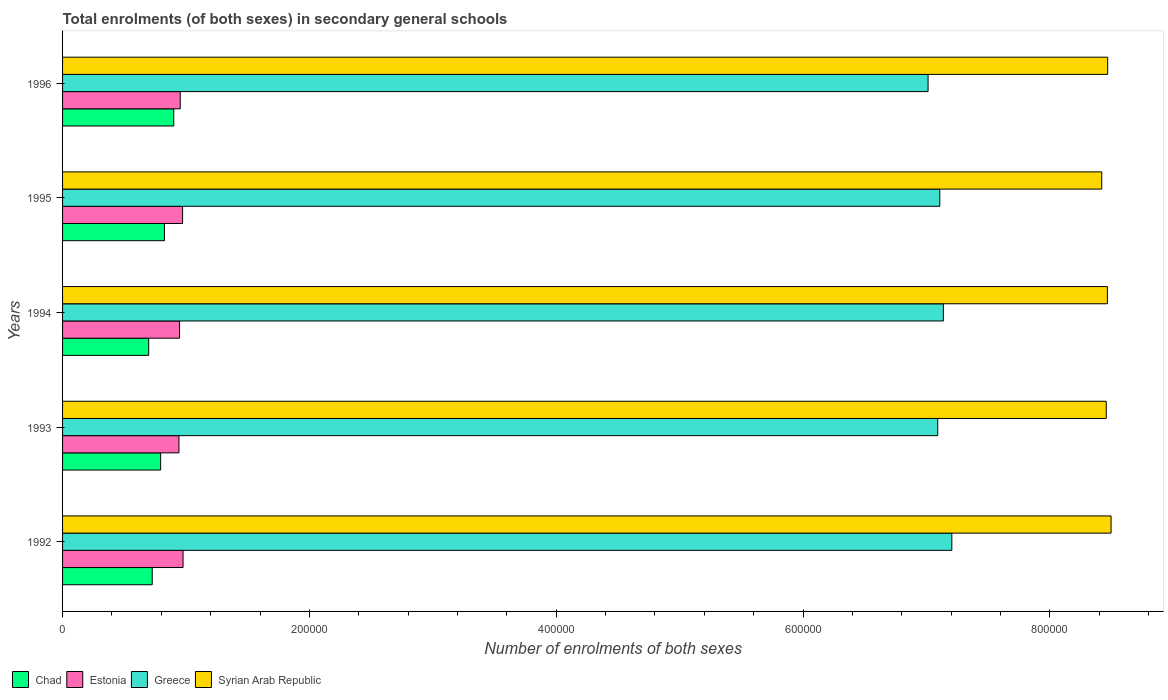How many groups of bars are there?
Keep it short and to the point. 5. How many bars are there on the 2nd tick from the top?
Make the answer very short. 4. How many bars are there on the 3rd tick from the bottom?
Your answer should be very brief. 4. What is the number of enrolments in secondary schools in Chad in 1992?
Your answer should be compact. 7.26e+04. Across all years, what is the maximum number of enrolments in secondary schools in Chad?
Make the answer very short. 9.01e+04. Across all years, what is the minimum number of enrolments in secondary schools in Syrian Arab Republic?
Give a very brief answer. 8.42e+05. In which year was the number of enrolments in secondary schools in Chad maximum?
Provide a succinct answer. 1996. In which year was the number of enrolments in secondary schools in Greece minimum?
Make the answer very short. 1996. What is the total number of enrolments in secondary schools in Chad in the graph?
Keep it short and to the point. 3.95e+05. What is the difference between the number of enrolments in secondary schools in Estonia in 1992 and that in 1993?
Give a very brief answer. 3318. What is the difference between the number of enrolments in secondary schools in Syrian Arab Republic in 1992 and the number of enrolments in secondary schools in Chad in 1996?
Your answer should be very brief. 7.59e+05. What is the average number of enrolments in secondary schools in Syrian Arab Republic per year?
Keep it short and to the point. 8.46e+05. In the year 1994, what is the difference between the number of enrolments in secondary schools in Syrian Arab Republic and number of enrolments in secondary schools in Estonia?
Make the answer very short. 7.52e+05. In how many years, is the number of enrolments in secondary schools in Estonia greater than 760000 ?
Provide a short and direct response. 0. What is the ratio of the number of enrolments in secondary schools in Greece in 1994 to that in 1995?
Your answer should be compact. 1. What is the difference between the highest and the second highest number of enrolments in secondary schools in Chad?
Offer a terse response. 7541. What is the difference between the highest and the lowest number of enrolments in secondary schools in Greece?
Offer a terse response. 1.92e+04. In how many years, is the number of enrolments in secondary schools in Syrian Arab Republic greater than the average number of enrolments in secondary schools in Syrian Arab Republic taken over all years?
Give a very brief answer. 3. Is the sum of the number of enrolments in secondary schools in Greece in 1992 and 1994 greater than the maximum number of enrolments in secondary schools in Estonia across all years?
Your response must be concise. Yes. Is it the case that in every year, the sum of the number of enrolments in secondary schools in Syrian Arab Republic and number of enrolments in secondary schools in Greece is greater than the sum of number of enrolments in secondary schools in Estonia and number of enrolments in secondary schools in Chad?
Your answer should be very brief. Yes. What does the 3rd bar from the top in 1993 represents?
Give a very brief answer. Estonia. What does the 1st bar from the bottom in 1995 represents?
Offer a very short reply. Chad. Is it the case that in every year, the sum of the number of enrolments in secondary schools in Chad and number of enrolments in secondary schools in Greece is greater than the number of enrolments in secondary schools in Syrian Arab Republic?
Make the answer very short. No. Are all the bars in the graph horizontal?
Give a very brief answer. Yes. Does the graph contain any zero values?
Ensure brevity in your answer.  No. Does the graph contain grids?
Your answer should be compact. No. Where does the legend appear in the graph?
Your answer should be very brief. Bottom left. How are the legend labels stacked?
Give a very brief answer. Horizontal. What is the title of the graph?
Your answer should be compact. Total enrolments (of both sexes) in secondary general schools. What is the label or title of the X-axis?
Keep it short and to the point. Number of enrolments of both sexes. What is the Number of enrolments of both sexes in Chad in 1992?
Your answer should be very brief. 7.26e+04. What is the Number of enrolments of both sexes in Estonia in 1992?
Your answer should be compact. 9.76e+04. What is the Number of enrolments of both sexes in Greece in 1992?
Offer a terse response. 7.21e+05. What is the Number of enrolments of both sexes in Syrian Arab Republic in 1992?
Provide a short and direct response. 8.50e+05. What is the Number of enrolments of both sexes of Chad in 1993?
Provide a succinct answer. 7.95e+04. What is the Number of enrolments of both sexes of Estonia in 1993?
Keep it short and to the point. 9.43e+04. What is the Number of enrolments of both sexes of Greece in 1993?
Your answer should be compact. 7.09e+05. What is the Number of enrolments of both sexes in Syrian Arab Republic in 1993?
Offer a very short reply. 8.46e+05. What is the Number of enrolments of both sexes in Chad in 1994?
Make the answer very short. 6.98e+04. What is the Number of enrolments of both sexes in Estonia in 1994?
Provide a short and direct response. 9.48e+04. What is the Number of enrolments of both sexes in Greece in 1994?
Your answer should be very brief. 7.14e+05. What is the Number of enrolments of both sexes in Syrian Arab Republic in 1994?
Ensure brevity in your answer.  8.47e+05. What is the Number of enrolments of both sexes in Chad in 1995?
Make the answer very short. 8.26e+04. What is the Number of enrolments of both sexes of Estonia in 1995?
Provide a succinct answer. 9.72e+04. What is the Number of enrolments of both sexes of Greece in 1995?
Give a very brief answer. 7.11e+05. What is the Number of enrolments of both sexes in Syrian Arab Republic in 1995?
Offer a very short reply. 8.42e+05. What is the Number of enrolments of both sexes of Chad in 1996?
Give a very brief answer. 9.01e+04. What is the Number of enrolments of both sexes in Estonia in 1996?
Make the answer very short. 9.53e+04. What is the Number of enrolments of both sexes in Greece in 1996?
Provide a short and direct response. 7.01e+05. What is the Number of enrolments of both sexes of Syrian Arab Republic in 1996?
Your answer should be compact. 8.47e+05. Across all years, what is the maximum Number of enrolments of both sexes in Chad?
Make the answer very short. 9.01e+04. Across all years, what is the maximum Number of enrolments of both sexes in Estonia?
Provide a short and direct response. 9.76e+04. Across all years, what is the maximum Number of enrolments of both sexes in Greece?
Your answer should be very brief. 7.21e+05. Across all years, what is the maximum Number of enrolments of both sexes in Syrian Arab Republic?
Keep it short and to the point. 8.50e+05. Across all years, what is the minimum Number of enrolments of both sexes in Chad?
Ensure brevity in your answer.  6.98e+04. Across all years, what is the minimum Number of enrolments of both sexes of Estonia?
Your answer should be compact. 9.43e+04. Across all years, what is the minimum Number of enrolments of both sexes of Greece?
Provide a succinct answer. 7.01e+05. Across all years, what is the minimum Number of enrolments of both sexes of Syrian Arab Republic?
Your answer should be very brief. 8.42e+05. What is the total Number of enrolments of both sexes in Chad in the graph?
Make the answer very short. 3.95e+05. What is the total Number of enrolments of both sexes in Estonia in the graph?
Your response must be concise. 4.79e+05. What is the total Number of enrolments of both sexes of Greece in the graph?
Provide a short and direct response. 3.56e+06. What is the total Number of enrolments of both sexes of Syrian Arab Republic in the graph?
Provide a short and direct response. 4.23e+06. What is the difference between the Number of enrolments of both sexes of Chad in 1992 and that in 1993?
Offer a very short reply. -6817. What is the difference between the Number of enrolments of both sexes in Estonia in 1992 and that in 1993?
Ensure brevity in your answer.  3318. What is the difference between the Number of enrolments of both sexes in Greece in 1992 and that in 1993?
Offer a terse response. 1.14e+04. What is the difference between the Number of enrolments of both sexes in Syrian Arab Republic in 1992 and that in 1993?
Make the answer very short. 3899. What is the difference between the Number of enrolments of both sexes of Chad in 1992 and that in 1994?
Provide a succinct answer. 2857. What is the difference between the Number of enrolments of both sexes of Estonia in 1992 and that in 1994?
Give a very brief answer. 2845. What is the difference between the Number of enrolments of both sexes in Greece in 1992 and that in 1994?
Provide a succinct answer. 6852. What is the difference between the Number of enrolments of both sexes in Syrian Arab Republic in 1992 and that in 1994?
Offer a terse response. 2980. What is the difference between the Number of enrolments of both sexes in Chad in 1992 and that in 1995?
Your answer should be very brief. -9918. What is the difference between the Number of enrolments of both sexes of Estonia in 1992 and that in 1995?
Offer a terse response. 379. What is the difference between the Number of enrolments of both sexes in Greece in 1992 and that in 1995?
Keep it short and to the point. 9752. What is the difference between the Number of enrolments of both sexes in Syrian Arab Republic in 1992 and that in 1995?
Keep it short and to the point. 7566. What is the difference between the Number of enrolments of both sexes of Chad in 1992 and that in 1996?
Keep it short and to the point. -1.75e+04. What is the difference between the Number of enrolments of both sexes in Estonia in 1992 and that in 1996?
Give a very brief answer. 2283. What is the difference between the Number of enrolments of both sexes in Greece in 1992 and that in 1996?
Provide a short and direct response. 1.92e+04. What is the difference between the Number of enrolments of both sexes in Syrian Arab Republic in 1992 and that in 1996?
Offer a very short reply. 2752. What is the difference between the Number of enrolments of both sexes of Chad in 1993 and that in 1994?
Your response must be concise. 9674. What is the difference between the Number of enrolments of both sexes in Estonia in 1993 and that in 1994?
Provide a short and direct response. -473. What is the difference between the Number of enrolments of both sexes in Greece in 1993 and that in 1994?
Offer a very short reply. -4578. What is the difference between the Number of enrolments of both sexes in Syrian Arab Republic in 1993 and that in 1994?
Offer a terse response. -919. What is the difference between the Number of enrolments of both sexes of Chad in 1993 and that in 1995?
Keep it short and to the point. -3101. What is the difference between the Number of enrolments of both sexes in Estonia in 1993 and that in 1995?
Ensure brevity in your answer.  -2939. What is the difference between the Number of enrolments of both sexes of Greece in 1993 and that in 1995?
Provide a succinct answer. -1678. What is the difference between the Number of enrolments of both sexes of Syrian Arab Republic in 1993 and that in 1995?
Make the answer very short. 3667. What is the difference between the Number of enrolments of both sexes in Chad in 1993 and that in 1996?
Make the answer very short. -1.06e+04. What is the difference between the Number of enrolments of both sexes in Estonia in 1993 and that in 1996?
Offer a very short reply. -1035. What is the difference between the Number of enrolments of both sexes in Greece in 1993 and that in 1996?
Provide a short and direct response. 7818. What is the difference between the Number of enrolments of both sexes in Syrian Arab Republic in 1993 and that in 1996?
Your answer should be compact. -1147. What is the difference between the Number of enrolments of both sexes in Chad in 1994 and that in 1995?
Ensure brevity in your answer.  -1.28e+04. What is the difference between the Number of enrolments of both sexes in Estonia in 1994 and that in 1995?
Provide a succinct answer. -2466. What is the difference between the Number of enrolments of both sexes of Greece in 1994 and that in 1995?
Provide a succinct answer. 2900. What is the difference between the Number of enrolments of both sexes in Syrian Arab Republic in 1994 and that in 1995?
Offer a very short reply. 4586. What is the difference between the Number of enrolments of both sexes in Chad in 1994 and that in 1996?
Give a very brief answer. -2.03e+04. What is the difference between the Number of enrolments of both sexes of Estonia in 1994 and that in 1996?
Give a very brief answer. -562. What is the difference between the Number of enrolments of both sexes of Greece in 1994 and that in 1996?
Make the answer very short. 1.24e+04. What is the difference between the Number of enrolments of both sexes in Syrian Arab Republic in 1994 and that in 1996?
Make the answer very short. -228. What is the difference between the Number of enrolments of both sexes of Chad in 1995 and that in 1996?
Make the answer very short. -7541. What is the difference between the Number of enrolments of both sexes of Estonia in 1995 and that in 1996?
Provide a short and direct response. 1904. What is the difference between the Number of enrolments of both sexes of Greece in 1995 and that in 1996?
Your answer should be very brief. 9496. What is the difference between the Number of enrolments of both sexes in Syrian Arab Republic in 1995 and that in 1996?
Your response must be concise. -4814. What is the difference between the Number of enrolments of both sexes of Chad in 1992 and the Number of enrolments of both sexes of Estonia in 1993?
Provide a short and direct response. -2.17e+04. What is the difference between the Number of enrolments of both sexes in Chad in 1992 and the Number of enrolments of both sexes in Greece in 1993?
Provide a short and direct response. -6.36e+05. What is the difference between the Number of enrolments of both sexes in Chad in 1992 and the Number of enrolments of both sexes in Syrian Arab Republic in 1993?
Your response must be concise. -7.73e+05. What is the difference between the Number of enrolments of both sexes of Estonia in 1992 and the Number of enrolments of both sexes of Greece in 1993?
Offer a very short reply. -6.11e+05. What is the difference between the Number of enrolments of both sexes in Estonia in 1992 and the Number of enrolments of both sexes in Syrian Arab Republic in 1993?
Give a very brief answer. -7.48e+05. What is the difference between the Number of enrolments of both sexes in Greece in 1992 and the Number of enrolments of both sexes in Syrian Arab Republic in 1993?
Make the answer very short. -1.25e+05. What is the difference between the Number of enrolments of both sexes in Chad in 1992 and the Number of enrolments of both sexes in Estonia in 1994?
Ensure brevity in your answer.  -2.21e+04. What is the difference between the Number of enrolments of both sexes of Chad in 1992 and the Number of enrolments of both sexes of Greece in 1994?
Your answer should be compact. -6.41e+05. What is the difference between the Number of enrolments of both sexes of Chad in 1992 and the Number of enrolments of both sexes of Syrian Arab Republic in 1994?
Keep it short and to the point. -7.74e+05. What is the difference between the Number of enrolments of both sexes in Estonia in 1992 and the Number of enrolments of both sexes in Greece in 1994?
Provide a succinct answer. -6.16e+05. What is the difference between the Number of enrolments of both sexes of Estonia in 1992 and the Number of enrolments of both sexes of Syrian Arab Republic in 1994?
Make the answer very short. -7.49e+05. What is the difference between the Number of enrolments of both sexes in Greece in 1992 and the Number of enrolments of both sexes in Syrian Arab Republic in 1994?
Keep it short and to the point. -1.26e+05. What is the difference between the Number of enrolments of both sexes in Chad in 1992 and the Number of enrolments of both sexes in Estonia in 1995?
Give a very brief answer. -2.46e+04. What is the difference between the Number of enrolments of both sexes in Chad in 1992 and the Number of enrolments of both sexes in Greece in 1995?
Provide a short and direct response. -6.38e+05. What is the difference between the Number of enrolments of both sexes in Chad in 1992 and the Number of enrolments of both sexes in Syrian Arab Republic in 1995?
Keep it short and to the point. -7.69e+05. What is the difference between the Number of enrolments of both sexes in Estonia in 1992 and the Number of enrolments of both sexes in Greece in 1995?
Keep it short and to the point. -6.13e+05. What is the difference between the Number of enrolments of both sexes in Estonia in 1992 and the Number of enrolments of both sexes in Syrian Arab Republic in 1995?
Offer a very short reply. -7.44e+05. What is the difference between the Number of enrolments of both sexes of Greece in 1992 and the Number of enrolments of both sexes of Syrian Arab Republic in 1995?
Give a very brief answer. -1.21e+05. What is the difference between the Number of enrolments of both sexes of Chad in 1992 and the Number of enrolments of both sexes of Estonia in 1996?
Give a very brief answer. -2.27e+04. What is the difference between the Number of enrolments of both sexes of Chad in 1992 and the Number of enrolments of both sexes of Greece in 1996?
Your answer should be compact. -6.29e+05. What is the difference between the Number of enrolments of both sexes in Chad in 1992 and the Number of enrolments of both sexes in Syrian Arab Republic in 1996?
Your answer should be compact. -7.74e+05. What is the difference between the Number of enrolments of both sexes of Estonia in 1992 and the Number of enrolments of both sexes of Greece in 1996?
Ensure brevity in your answer.  -6.04e+05. What is the difference between the Number of enrolments of both sexes of Estonia in 1992 and the Number of enrolments of both sexes of Syrian Arab Republic in 1996?
Offer a very short reply. -7.49e+05. What is the difference between the Number of enrolments of both sexes in Greece in 1992 and the Number of enrolments of both sexes in Syrian Arab Republic in 1996?
Provide a short and direct response. -1.26e+05. What is the difference between the Number of enrolments of both sexes of Chad in 1993 and the Number of enrolments of both sexes of Estonia in 1994?
Ensure brevity in your answer.  -1.53e+04. What is the difference between the Number of enrolments of both sexes of Chad in 1993 and the Number of enrolments of both sexes of Greece in 1994?
Provide a succinct answer. -6.34e+05. What is the difference between the Number of enrolments of both sexes of Chad in 1993 and the Number of enrolments of both sexes of Syrian Arab Republic in 1994?
Offer a terse response. -7.67e+05. What is the difference between the Number of enrolments of both sexes in Estonia in 1993 and the Number of enrolments of both sexes in Greece in 1994?
Provide a succinct answer. -6.19e+05. What is the difference between the Number of enrolments of both sexes of Estonia in 1993 and the Number of enrolments of both sexes of Syrian Arab Republic in 1994?
Ensure brevity in your answer.  -7.52e+05. What is the difference between the Number of enrolments of both sexes of Greece in 1993 and the Number of enrolments of both sexes of Syrian Arab Republic in 1994?
Offer a very short reply. -1.37e+05. What is the difference between the Number of enrolments of both sexes of Chad in 1993 and the Number of enrolments of both sexes of Estonia in 1995?
Your answer should be very brief. -1.78e+04. What is the difference between the Number of enrolments of both sexes in Chad in 1993 and the Number of enrolments of both sexes in Greece in 1995?
Your response must be concise. -6.31e+05. What is the difference between the Number of enrolments of both sexes in Chad in 1993 and the Number of enrolments of both sexes in Syrian Arab Republic in 1995?
Give a very brief answer. -7.63e+05. What is the difference between the Number of enrolments of both sexes in Estonia in 1993 and the Number of enrolments of both sexes in Greece in 1995?
Your answer should be compact. -6.16e+05. What is the difference between the Number of enrolments of both sexes in Estonia in 1993 and the Number of enrolments of both sexes in Syrian Arab Republic in 1995?
Offer a very short reply. -7.48e+05. What is the difference between the Number of enrolments of both sexes of Greece in 1993 and the Number of enrolments of both sexes of Syrian Arab Republic in 1995?
Provide a short and direct response. -1.33e+05. What is the difference between the Number of enrolments of both sexes in Chad in 1993 and the Number of enrolments of both sexes in Estonia in 1996?
Your answer should be very brief. -1.59e+04. What is the difference between the Number of enrolments of both sexes in Chad in 1993 and the Number of enrolments of both sexes in Greece in 1996?
Offer a terse response. -6.22e+05. What is the difference between the Number of enrolments of both sexes of Chad in 1993 and the Number of enrolments of both sexes of Syrian Arab Republic in 1996?
Give a very brief answer. -7.67e+05. What is the difference between the Number of enrolments of both sexes of Estonia in 1993 and the Number of enrolments of both sexes of Greece in 1996?
Make the answer very short. -6.07e+05. What is the difference between the Number of enrolments of both sexes in Estonia in 1993 and the Number of enrolments of both sexes in Syrian Arab Republic in 1996?
Your answer should be very brief. -7.52e+05. What is the difference between the Number of enrolments of both sexes of Greece in 1993 and the Number of enrolments of both sexes of Syrian Arab Republic in 1996?
Offer a very short reply. -1.38e+05. What is the difference between the Number of enrolments of both sexes of Chad in 1994 and the Number of enrolments of both sexes of Estonia in 1995?
Provide a short and direct response. -2.75e+04. What is the difference between the Number of enrolments of both sexes of Chad in 1994 and the Number of enrolments of both sexes of Greece in 1995?
Provide a short and direct response. -6.41e+05. What is the difference between the Number of enrolments of both sexes of Chad in 1994 and the Number of enrolments of both sexes of Syrian Arab Republic in 1995?
Offer a very short reply. -7.72e+05. What is the difference between the Number of enrolments of both sexes of Estonia in 1994 and the Number of enrolments of both sexes of Greece in 1995?
Ensure brevity in your answer.  -6.16e+05. What is the difference between the Number of enrolments of both sexes in Estonia in 1994 and the Number of enrolments of both sexes in Syrian Arab Republic in 1995?
Provide a short and direct response. -7.47e+05. What is the difference between the Number of enrolments of both sexes of Greece in 1994 and the Number of enrolments of both sexes of Syrian Arab Republic in 1995?
Ensure brevity in your answer.  -1.28e+05. What is the difference between the Number of enrolments of both sexes of Chad in 1994 and the Number of enrolments of both sexes of Estonia in 1996?
Your answer should be compact. -2.56e+04. What is the difference between the Number of enrolments of both sexes in Chad in 1994 and the Number of enrolments of both sexes in Greece in 1996?
Your response must be concise. -6.31e+05. What is the difference between the Number of enrolments of both sexes of Chad in 1994 and the Number of enrolments of both sexes of Syrian Arab Republic in 1996?
Provide a succinct answer. -7.77e+05. What is the difference between the Number of enrolments of both sexes of Estonia in 1994 and the Number of enrolments of both sexes of Greece in 1996?
Keep it short and to the point. -6.06e+05. What is the difference between the Number of enrolments of both sexes in Estonia in 1994 and the Number of enrolments of both sexes in Syrian Arab Republic in 1996?
Provide a short and direct response. -7.52e+05. What is the difference between the Number of enrolments of both sexes in Greece in 1994 and the Number of enrolments of both sexes in Syrian Arab Republic in 1996?
Provide a short and direct response. -1.33e+05. What is the difference between the Number of enrolments of both sexes of Chad in 1995 and the Number of enrolments of both sexes of Estonia in 1996?
Provide a succinct answer. -1.28e+04. What is the difference between the Number of enrolments of both sexes in Chad in 1995 and the Number of enrolments of both sexes in Greece in 1996?
Keep it short and to the point. -6.19e+05. What is the difference between the Number of enrolments of both sexes of Chad in 1995 and the Number of enrolments of both sexes of Syrian Arab Republic in 1996?
Your response must be concise. -7.64e+05. What is the difference between the Number of enrolments of both sexes of Estonia in 1995 and the Number of enrolments of both sexes of Greece in 1996?
Give a very brief answer. -6.04e+05. What is the difference between the Number of enrolments of both sexes in Estonia in 1995 and the Number of enrolments of both sexes in Syrian Arab Republic in 1996?
Offer a very short reply. -7.50e+05. What is the difference between the Number of enrolments of both sexes in Greece in 1995 and the Number of enrolments of both sexes in Syrian Arab Republic in 1996?
Ensure brevity in your answer.  -1.36e+05. What is the average Number of enrolments of both sexes in Chad per year?
Offer a very short reply. 7.89e+04. What is the average Number of enrolments of both sexes in Estonia per year?
Your answer should be compact. 9.59e+04. What is the average Number of enrolments of both sexes of Greece per year?
Give a very brief answer. 7.11e+05. What is the average Number of enrolments of both sexes in Syrian Arab Republic per year?
Offer a very short reply. 8.46e+05. In the year 1992, what is the difference between the Number of enrolments of both sexes of Chad and Number of enrolments of both sexes of Estonia?
Give a very brief answer. -2.50e+04. In the year 1992, what is the difference between the Number of enrolments of both sexes in Chad and Number of enrolments of both sexes in Greece?
Your answer should be very brief. -6.48e+05. In the year 1992, what is the difference between the Number of enrolments of both sexes in Chad and Number of enrolments of both sexes in Syrian Arab Republic?
Provide a succinct answer. -7.77e+05. In the year 1992, what is the difference between the Number of enrolments of both sexes in Estonia and Number of enrolments of both sexes in Greece?
Your answer should be compact. -6.23e+05. In the year 1992, what is the difference between the Number of enrolments of both sexes of Estonia and Number of enrolments of both sexes of Syrian Arab Republic?
Ensure brevity in your answer.  -7.52e+05. In the year 1992, what is the difference between the Number of enrolments of both sexes of Greece and Number of enrolments of both sexes of Syrian Arab Republic?
Provide a succinct answer. -1.29e+05. In the year 1993, what is the difference between the Number of enrolments of both sexes in Chad and Number of enrolments of both sexes in Estonia?
Provide a short and direct response. -1.48e+04. In the year 1993, what is the difference between the Number of enrolments of both sexes in Chad and Number of enrolments of both sexes in Greece?
Keep it short and to the point. -6.30e+05. In the year 1993, what is the difference between the Number of enrolments of both sexes of Chad and Number of enrolments of both sexes of Syrian Arab Republic?
Your answer should be compact. -7.66e+05. In the year 1993, what is the difference between the Number of enrolments of both sexes of Estonia and Number of enrolments of both sexes of Greece?
Make the answer very short. -6.15e+05. In the year 1993, what is the difference between the Number of enrolments of both sexes in Estonia and Number of enrolments of both sexes in Syrian Arab Republic?
Make the answer very short. -7.51e+05. In the year 1993, what is the difference between the Number of enrolments of both sexes in Greece and Number of enrolments of both sexes in Syrian Arab Republic?
Your response must be concise. -1.37e+05. In the year 1994, what is the difference between the Number of enrolments of both sexes of Chad and Number of enrolments of both sexes of Estonia?
Provide a succinct answer. -2.50e+04. In the year 1994, what is the difference between the Number of enrolments of both sexes of Chad and Number of enrolments of both sexes of Greece?
Provide a succinct answer. -6.44e+05. In the year 1994, what is the difference between the Number of enrolments of both sexes in Chad and Number of enrolments of both sexes in Syrian Arab Republic?
Provide a succinct answer. -7.77e+05. In the year 1994, what is the difference between the Number of enrolments of both sexes in Estonia and Number of enrolments of both sexes in Greece?
Provide a short and direct response. -6.19e+05. In the year 1994, what is the difference between the Number of enrolments of both sexes of Estonia and Number of enrolments of both sexes of Syrian Arab Republic?
Provide a short and direct response. -7.52e+05. In the year 1994, what is the difference between the Number of enrolments of both sexes of Greece and Number of enrolments of both sexes of Syrian Arab Republic?
Your answer should be compact. -1.33e+05. In the year 1995, what is the difference between the Number of enrolments of both sexes in Chad and Number of enrolments of both sexes in Estonia?
Your answer should be very brief. -1.47e+04. In the year 1995, what is the difference between the Number of enrolments of both sexes of Chad and Number of enrolments of both sexes of Greece?
Provide a succinct answer. -6.28e+05. In the year 1995, what is the difference between the Number of enrolments of both sexes of Chad and Number of enrolments of both sexes of Syrian Arab Republic?
Your answer should be very brief. -7.59e+05. In the year 1995, what is the difference between the Number of enrolments of both sexes of Estonia and Number of enrolments of both sexes of Greece?
Ensure brevity in your answer.  -6.14e+05. In the year 1995, what is the difference between the Number of enrolments of both sexes of Estonia and Number of enrolments of both sexes of Syrian Arab Republic?
Provide a succinct answer. -7.45e+05. In the year 1995, what is the difference between the Number of enrolments of both sexes of Greece and Number of enrolments of both sexes of Syrian Arab Republic?
Your answer should be compact. -1.31e+05. In the year 1996, what is the difference between the Number of enrolments of both sexes of Chad and Number of enrolments of both sexes of Estonia?
Provide a succinct answer. -5242. In the year 1996, what is the difference between the Number of enrolments of both sexes of Chad and Number of enrolments of both sexes of Greece?
Ensure brevity in your answer.  -6.11e+05. In the year 1996, what is the difference between the Number of enrolments of both sexes of Chad and Number of enrolments of both sexes of Syrian Arab Republic?
Make the answer very short. -7.57e+05. In the year 1996, what is the difference between the Number of enrolments of both sexes in Estonia and Number of enrolments of both sexes in Greece?
Your answer should be very brief. -6.06e+05. In the year 1996, what is the difference between the Number of enrolments of both sexes in Estonia and Number of enrolments of both sexes in Syrian Arab Republic?
Your answer should be very brief. -7.51e+05. In the year 1996, what is the difference between the Number of enrolments of both sexes in Greece and Number of enrolments of both sexes in Syrian Arab Republic?
Keep it short and to the point. -1.46e+05. What is the ratio of the Number of enrolments of both sexes of Chad in 1992 to that in 1993?
Your answer should be very brief. 0.91. What is the ratio of the Number of enrolments of both sexes of Estonia in 1992 to that in 1993?
Provide a succinct answer. 1.04. What is the ratio of the Number of enrolments of both sexes of Greece in 1992 to that in 1993?
Keep it short and to the point. 1.02. What is the ratio of the Number of enrolments of both sexes in Syrian Arab Republic in 1992 to that in 1993?
Make the answer very short. 1. What is the ratio of the Number of enrolments of both sexes in Chad in 1992 to that in 1994?
Keep it short and to the point. 1.04. What is the ratio of the Number of enrolments of both sexes in Estonia in 1992 to that in 1994?
Give a very brief answer. 1.03. What is the ratio of the Number of enrolments of both sexes of Greece in 1992 to that in 1994?
Your response must be concise. 1.01. What is the ratio of the Number of enrolments of both sexes in Syrian Arab Republic in 1992 to that in 1994?
Give a very brief answer. 1. What is the ratio of the Number of enrolments of both sexes of Chad in 1992 to that in 1995?
Make the answer very short. 0.88. What is the ratio of the Number of enrolments of both sexes of Estonia in 1992 to that in 1995?
Keep it short and to the point. 1. What is the ratio of the Number of enrolments of both sexes in Greece in 1992 to that in 1995?
Keep it short and to the point. 1.01. What is the ratio of the Number of enrolments of both sexes of Chad in 1992 to that in 1996?
Provide a short and direct response. 0.81. What is the ratio of the Number of enrolments of both sexes of Estonia in 1992 to that in 1996?
Your response must be concise. 1.02. What is the ratio of the Number of enrolments of both sexes of Greece in 1992 to that in 1996?
Your answer should be compact. 1.03. What is the ratio of the Number of enrolments of both sexes in Chad in 1993 to that in 1994?
Your response must be concise. 1.14. What is the ratio of the Number of enrolments of both sexes of Estonia in 1993 to that in 1994?
Provide a succinct answer. 0.99. What is the ratio of the Number of enrolments of both sexes in Chad in 1993 to that in 1995?
Provide a succinct answer. 0.96. What is the ratio of the Number of enrolments of both sexes in Estonia in 1993 to that in 1995?
Offer a very short reply. 0.97. What is the ratio of the Number of enrolments of both sexes of Greece in 1993 to that in 1995?
Keep it short and to the point. 1. What is the ratio of the Number of enrolments of both sexes in Syrian Arab Republic in 1993 to that in 1995?
Provide a short and direct response. 1. What is the ratio of the Number of enrolments of both sexes of Chad in 1993 to that in 1996?
Your response must be concise. 0.88. What is the ratio of the Number of enrolments of both sexes of Estonia in 1993 to that in 1996?
Your response must be concise. 0.99. What is the ratio of the Number of enrolments of both sexes in Greece in 1993 to that in 1996?
Keep it short and to the point. 1.01. What is the ratio of the Number of enrolments of both sexes in Syrian Arab Republic in 1993 to that in 1996?
Your response must be concise. 1. What is the ratio of the Number of enrolments of both sexes of Chad in 1994 to that in 1995?
Your response must be concise. 0.85. What is the ratio of the Number of enrolments of both sexes of Estonia in 1994 to that in 1995?
Ensure brevity in your answer.  0.97. What is the ratio of the Number of enrolments of both sexes in Greece in 1994 to that in 1995?
Provide a short and direct response. 1. What is the ratio of the Number of enrolments of both sexes of Syrian Arab Republic in 1994 to that in 1995?
Offer a terse response. 1.01. What is the ratio of the Number of enrolments of both sexes in Chad in 1994 to that in 1996?
Make the answer very short. 0.77. What is the ratio of the Number of enrolments of both sexes of Estonia in 1994 to that in 1996?
Make the answer very short. 0.99. What is the ratio of the Number of enrolments of both sexes in Greece in 1994 to that in 1996?
Ensure brevity in your answer.  1.02. What is the ratio of the Number of enrolments of both sexes in Syrian Arab Republic in 1994 to that in 1996?
Your response must be concise. 1. What is the ratio of the Number of enrolments of both sexes of Chad in 1995 to that in 1996?
Offer a terse response. 0.92. What is the ratio of the Number of enrolments of both sexes of Greece in 1995 to that in 1996?
Your response must be concise. 1.01. What is the difference between the highest and the second highest Number of enrolments of both sexes in Chad?
Provide a short and direct response. 7541. What is the difference between the highest and the second highest Number of enrolments of both sexes in Estonia?
Your answer should be compact. 379. What is the difference between the highest and the second highest Number of enrolments of both sexes of Greece?
Offer a terse response. 6852. What is the difference between the highest and the second highest Number of enrolments of both sexes of Syrian Arab Republic?
Give a very brief answer. 2752. What is the difference between the highest and the lowest Number of enrolments of both sexes of Chad?
Your answer should be very brief. 2.03e+04. What is the difference between the highest and the lowest Number of enrolments of both sexes of Estonia?
Offer a very short reply. 3318. What is the difference between the highest and the lowest Number of enrolments of both sexes in Greece?
Offer a terse response. 1.92e+04. What is the difference between the highest and the lowest Number of enrolments of both sexes in Syrian Arab Republic?
Provide a succinct answer. 7566. 